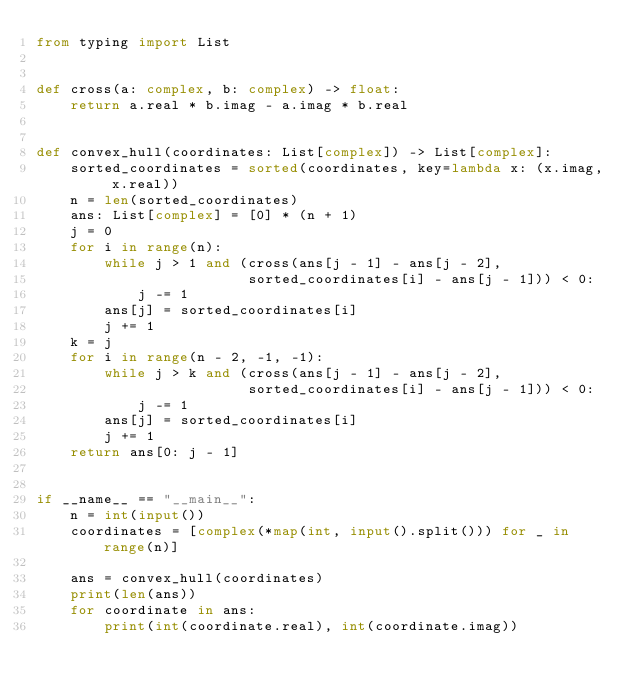Convert code to text. <code><loc_0><loc_0><loc_500><loc_500><_Python_>from typing import List


def cross(a: complex, b: complex) -> float:
    return a.real * b.imag - a.imag * b.real


def convex_hull(coordinates: List[complex]) -> List[complex]:
    sorted_coordinates = sorted(coordinates, key=lambda x: (x.imag, x.real))
    n = len(sorted_coordinates)
    ans: List[complex] = [0] * (n + 1)
    j = 0
    for i in range(n):
        while j > 1 and (cross(ans[j - 1] - ans[j - 2],
                         sorted_coordinates[i] - ans[j - 1])) < 0:
            j -= 1
        ans[j] = sorted_coordinates[i]
        j += 1
    k = j
    for i in range(n - 2, -1, -1):
        while j > k and (cross(ans[j - 1] - ans[j - 2],
                         sorted_coordinates[i] - ans[j - 1])) < 0:
            j -= 1
        ans[j] = sorted_coordinates[i]
        j += 1
    return ans[0: j - 1]


if __name__ == "__main__":
    n = int(input())
    coordinates = [complex(*map(int, input().split())) for _ in range(n)]

    ans = convex_hull(coordinates)
    print(len(ans))
    for coordinate in ans:
        print(int(coordinate.real), int(coordinate.imag))

</code> 